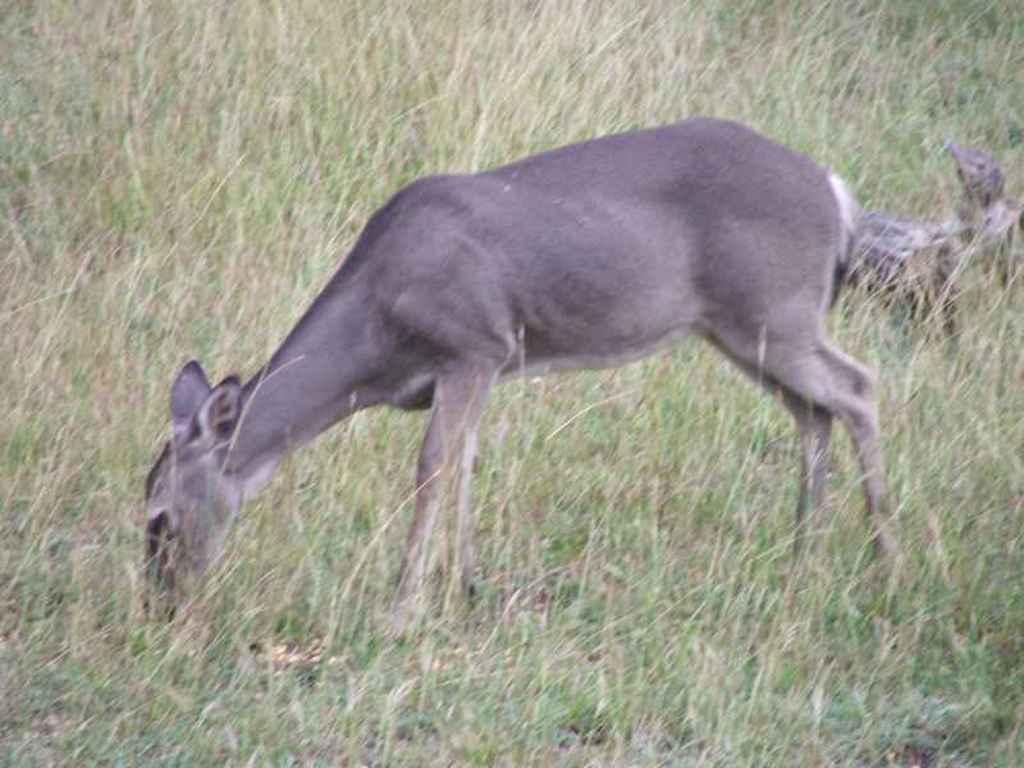Where was the image taken? The image was taken outdoors. What type of surface is visible in the image? There is a ground with grass in the image. What animal can be seen in the middle of the image? There is a deer in the middle of the image. What type of cap is the deer wearing in the image? There is no cap present on the deer in the image. Can you see any smoke coming from the deer in the image? There is no smoke present in the image, and the deer is not depicted as producing any smoke. 